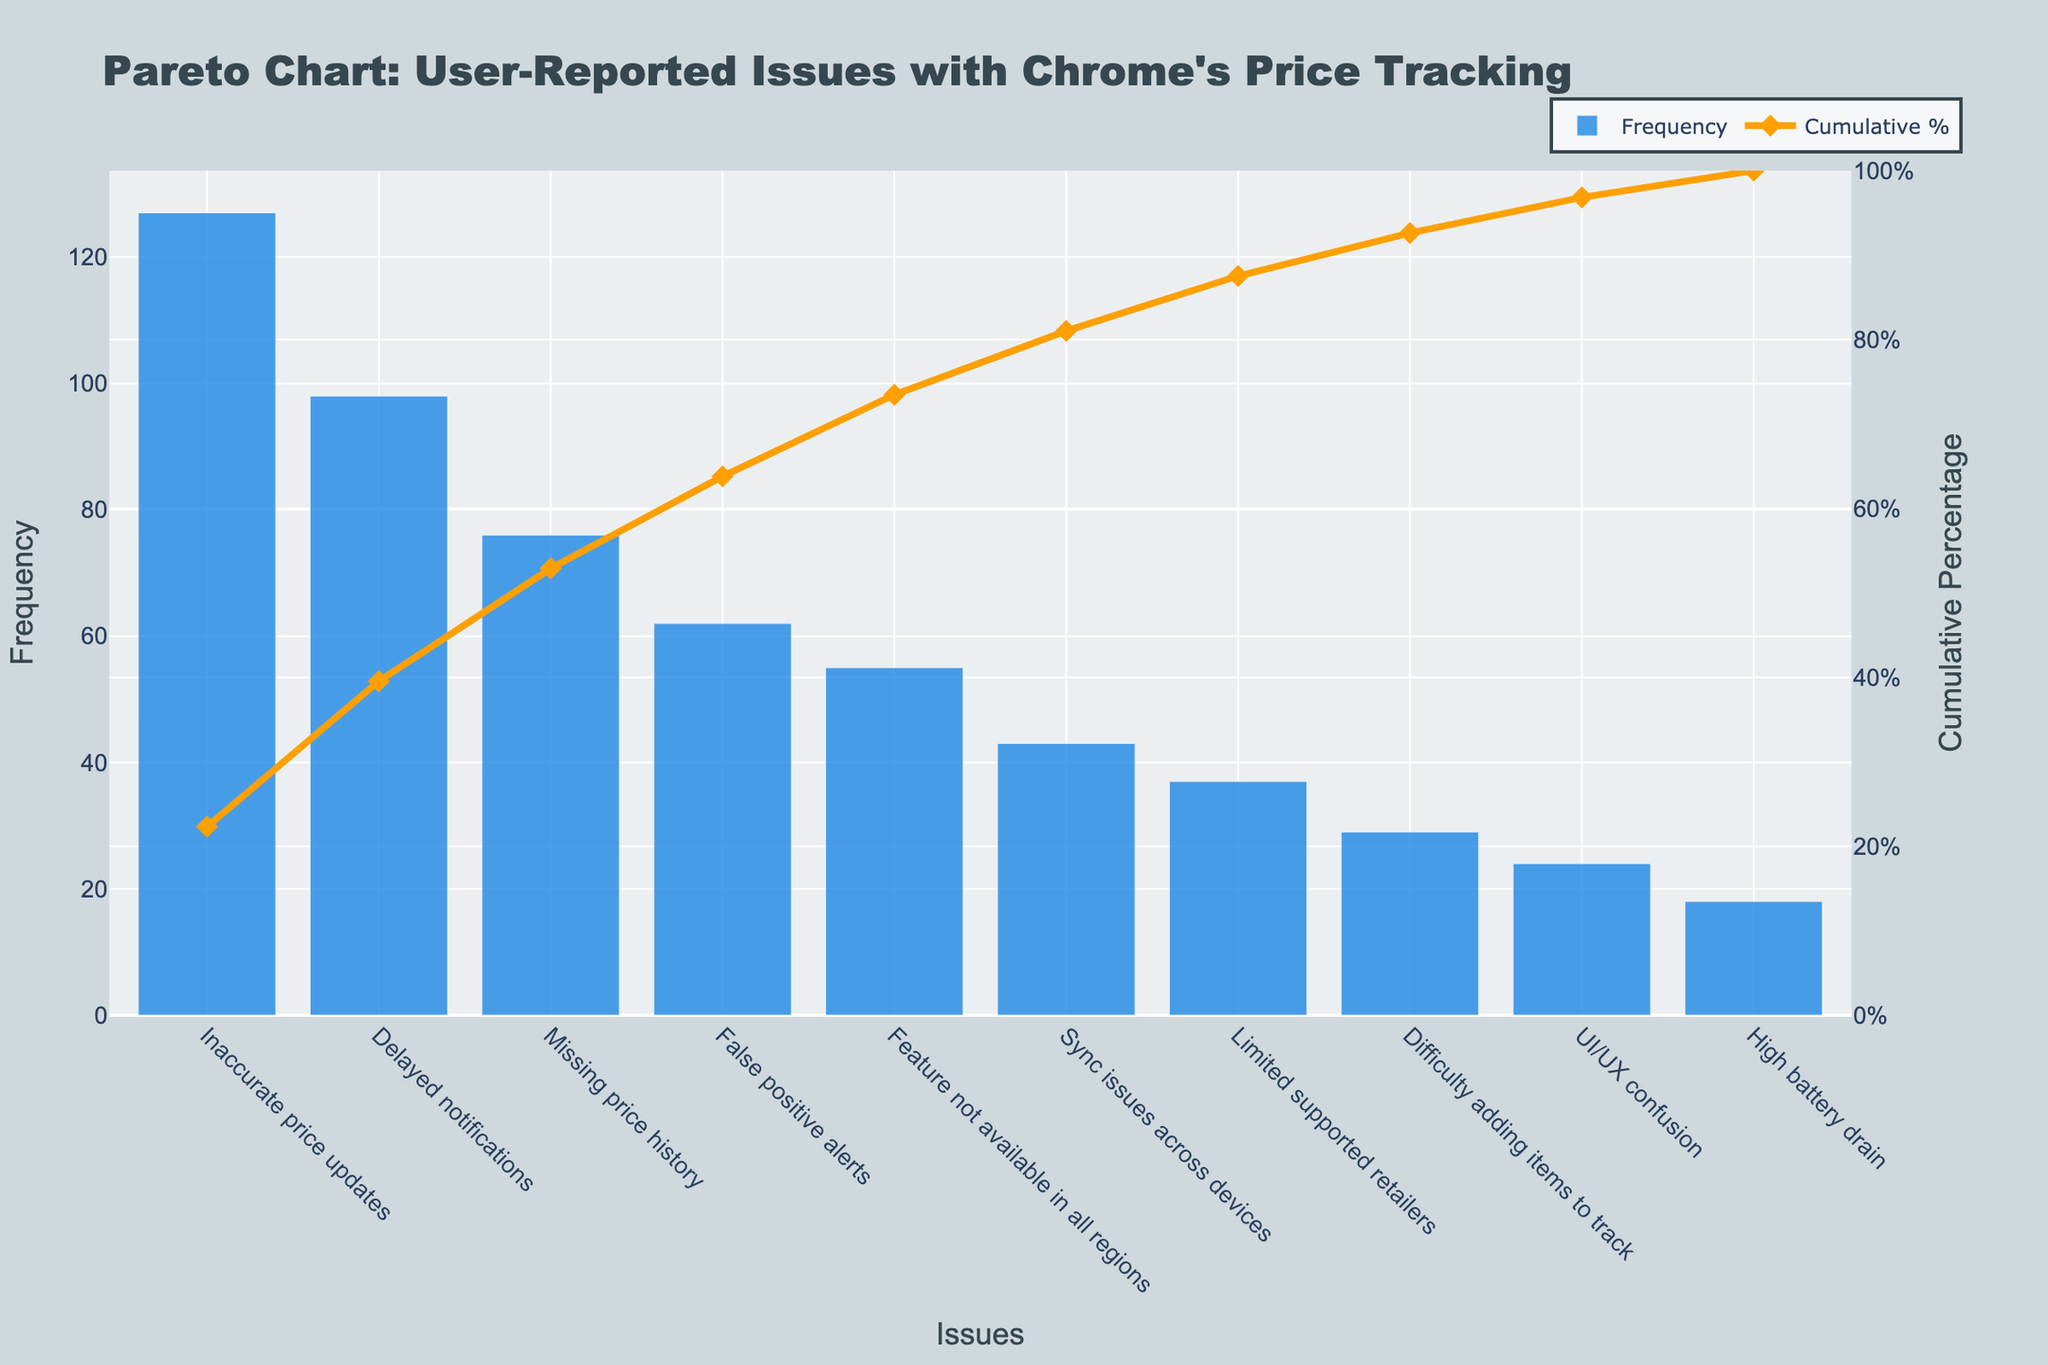What's the title of the chart? The title of the chart is displayed at the top and reads "Pareto Chart: User-Reported Issues with Chrome's Price Tracking"
Answer: Pareto Chart: User-Reported Issues with Chrome's Price Tracking What are the x-axis and y-axis labels? The x-axis label is "Issues" and the y-axis labels are "Frequency" on the left and "Cumulative Percentage" on the right
Answer: Issues, Frequency, Cumulative Percentage Which issue has the highest frequency? The bar with the highest frequency is labeled "Inaccurate price updates"
Answer: Inaccurate price updates What is the cumulative percentage of the top three most frequent issues? Identify the cumulative percentage at the third issue on the Pareto chart. The values are cumulative percentages: Inaccurate price updates + Delayed notifications + Missing price history. The chart shows the cumulative percentage exceeding 65% at the third point
Answer: Over 65% How many issues account for approximately 80% of the total frequency? Examine the cumulative percentage line and find the point closest to 80%. The value 80% is reached after the sixth issue, "Sync issues across devices"
Answer: Six issues Which issue has the lowest frequency, and what is its value? The bar with the lowest height represents the issue with the lowest frequency, which is at the far right of the x-axis. The issue is "High battery drain" with a frequency of 18
Answer: High battery drain, 18 Compare the frequency of "Limited supported retailers" and "Sync issues across devices". Which one is higher and by how much? The "Limited supported retailers" frequency is 37, and "Sync issues across devices" frequency is 43. The difference is 43 - 37
Answer: Sync issues across devices by 6 What is the cumulative percentage right after "Delayed notifications"? Find the cumulative percentage immediately following "Delayed notifications" in the line chart. The value is a bit above 50%
Answer: Over 50% What is the sum of frequencies of "Feature not available in all regions" and "False positive alerts"? Add the frequencies of "False positive alerts" (62) and "Feature not available in all regions" (55)
Answer: 117 Which issues cumulatively cover more than 50% of the total reported issues? Look for the segment on the cumulative percentage line that indicates the cumulative total surpassing 50%. The issues up to the second issue, "Delayed notifications", cumulatively cover more than 50%
Answer: Inaccurate price updates, Delayed notifications 